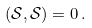Convert formula to latex. <formula><loc_0><loc_0><loc_500><loc_500>( \mathcal { S } , \mathcal { S } ) = 0 \, .</formula> 